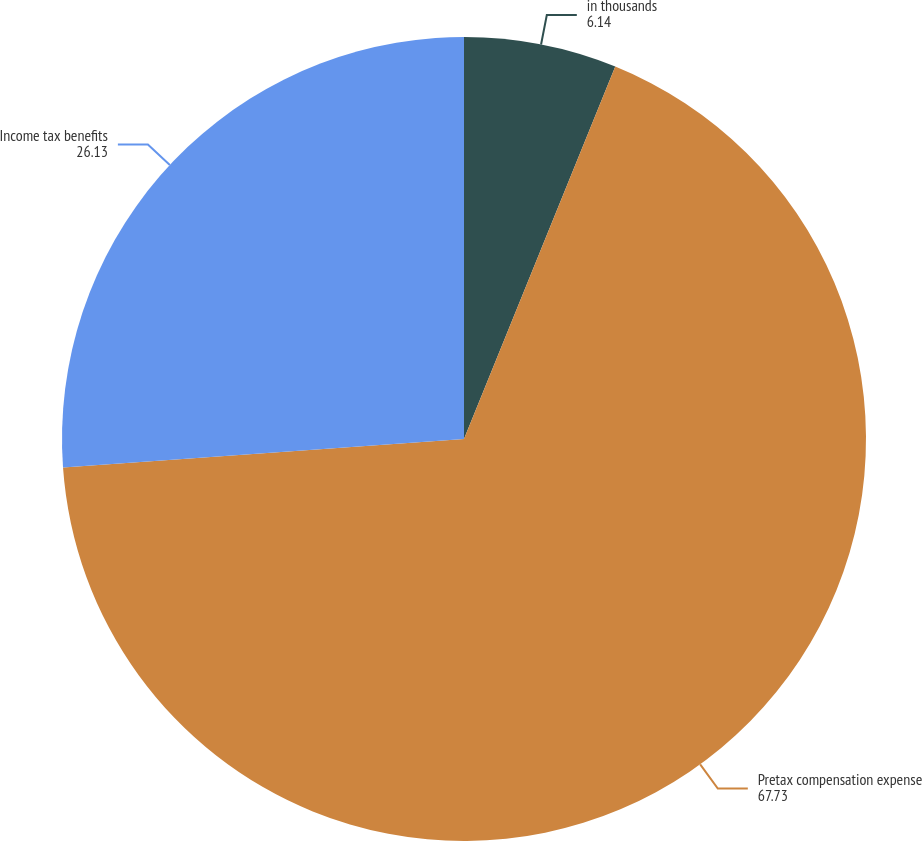<chart> <loc_0><loc_0><loc_500><loc_500><pie_chart><fcel>in thousands<fcel>Pretax compensation expense<fcel>Income tax benefits<nl><fcel>6.14%<fcel>67.73%<fcel>26.13%<nl></chart> 